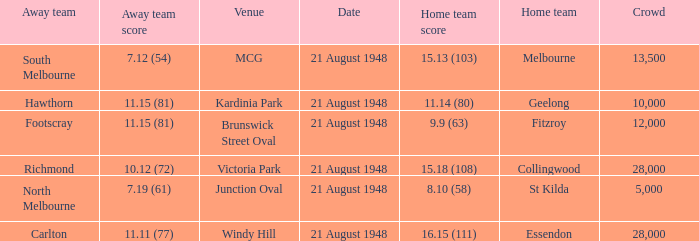What is the score for the home team when south melbourne is the away team? 15.13 (103). 